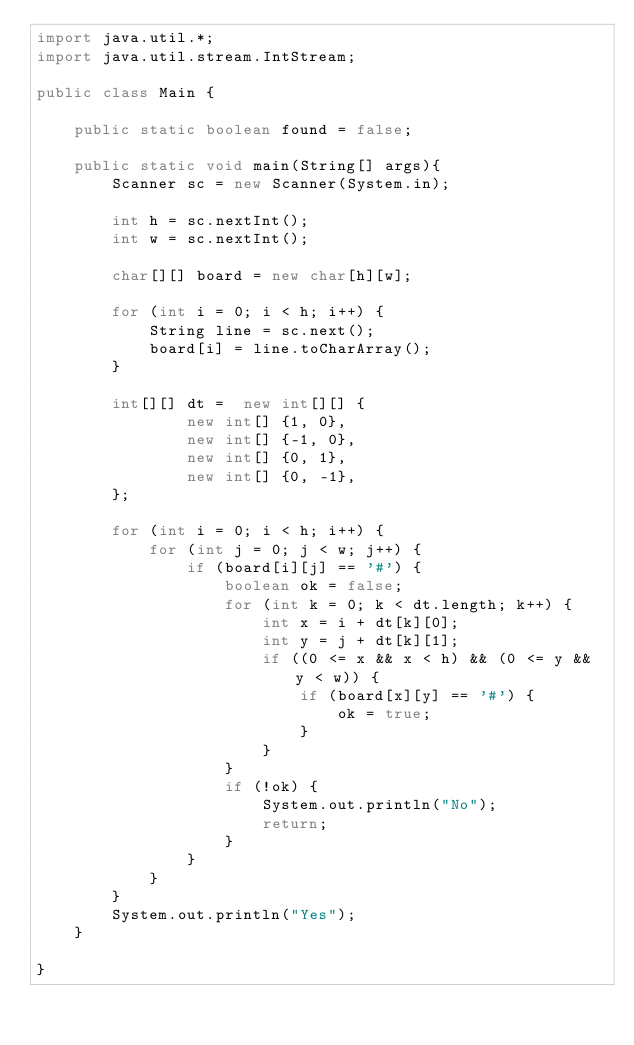<code> <loc_0><loc_0><loc_500><loc_500><_Java_>import java.util.*;
import java.util.stream.IntStream;

public class Main {

    public static boolean found = false;

    public static void main(String[] args){
        Scanner sc = new Scanner(System.in);

        int h = sc.nextInt();
        int w = sc.nextInt();

        char[][] board = new char[h][w];

        for (int i = 0; i < h; i++) {
            String line = sc.next();
            board[i] = line.toCharArray();
        }

        int[][] dt =  new int[][] {
                new int[] {1, 0},
                new int[] {-1, 0},
                new int[] {0, 1},
                new int[] {0, -1},
        };

        for (int i = 0; i < h; i++) {
            for (int j = 0; j < w; j++) {
                if (board[i][j] == '#') {
                    boolean ok = false;
                    for (int k = 0; k < dt.length; k++) {
                        int x = i + dt[k][0];
                        int y = j + dt[k][1];
                        if ((0 <= x && x < h) && (0 <= y && y < w)) {
                            if (board[x][y] == '#') {
                                ok = true;
                            }
                        }
                    }
                    if (!ok) {
                        System.out.println("No");
                        return;
                    }
                }
            }
        }
        System.out.println("Yes");
    }

}</code> 